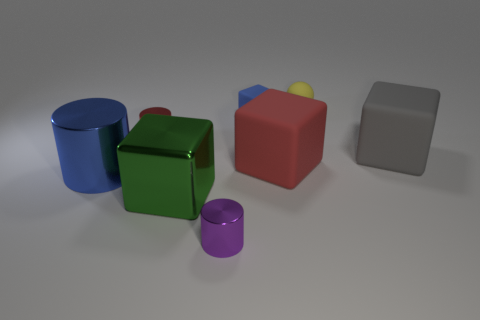There is a tiny object that is made of the same material as the yellow sphere; what is its color? The tiny object made from the same material as the yellow sphere appears to be purple in color. 